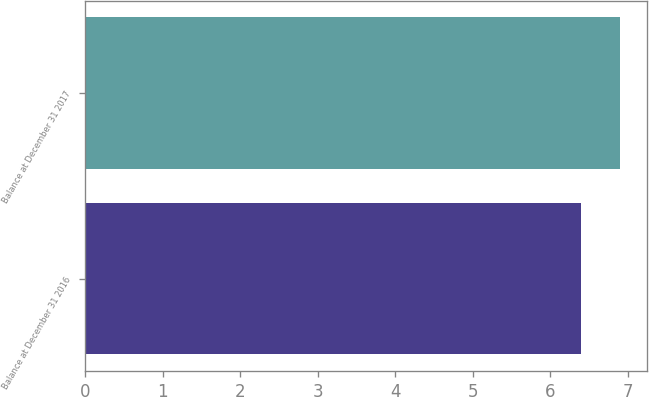Convert chart to OTSL. <chart><loc_0><loc_0><loc_500><loc_500><bar_chart><fcel>Balance at December 31 2016<fcel>Balance at December 31 2017<nl><fcel>6.4<fcel>6.9<nl></chart> 